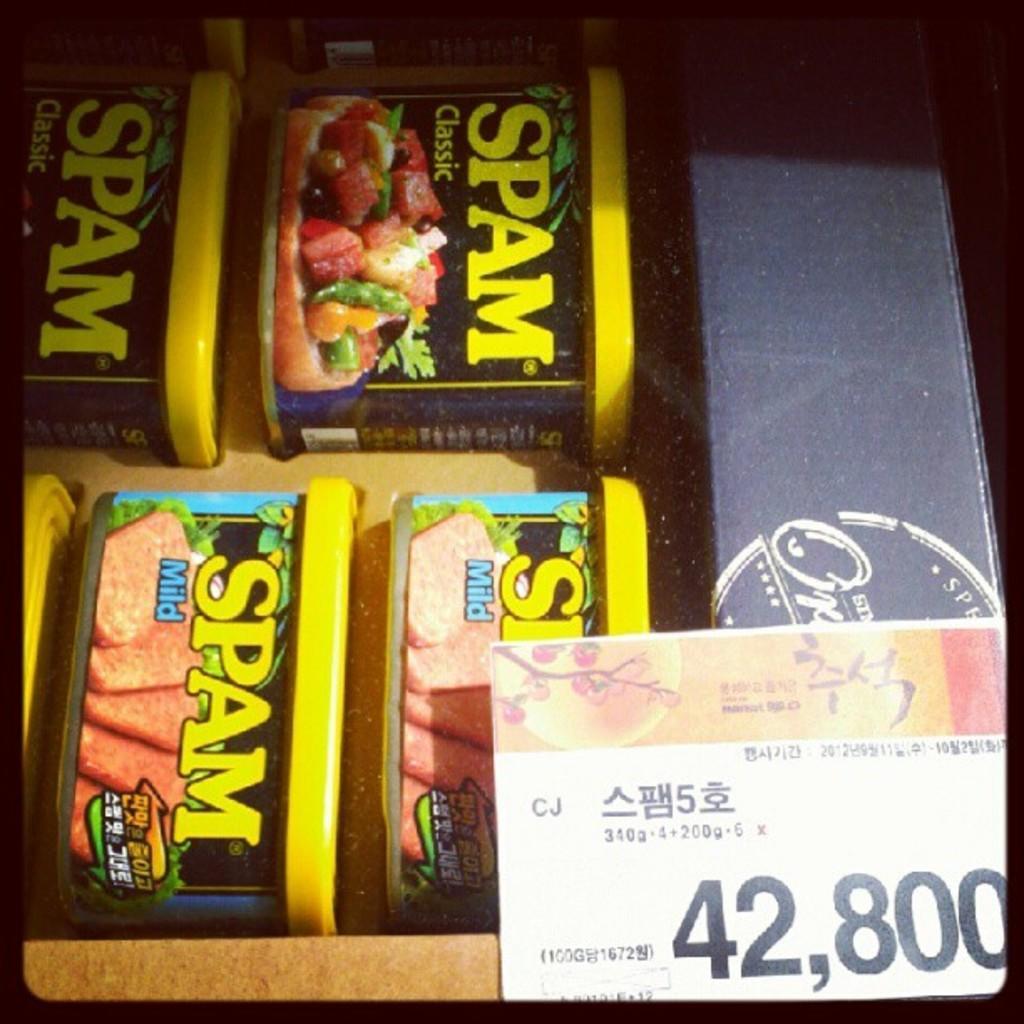How would you summarize this image in a sentence or two? In this image, we can see boxes with sticker. Right side bottom, there is a price tag. The borders of the image, we can see black color. 